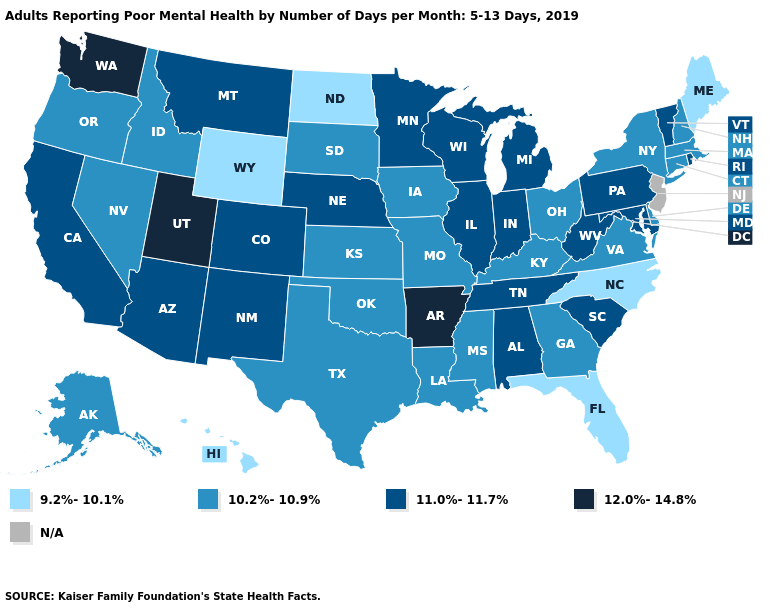Which states hav the highest value in the Northeast?
Be succinct. Pennsylvania, Rhode Island, Vermont. Does the first symbol in the legend represent the smallest category?
Short answer required. Yes. Which states hav the highest value in the MidWest?
Keep it brief. Illinois, Indiana, Michigan, Minnesota, Nebraska, Wisconsin. Among the states that border Massachusetts , which have the lowest value?
Concise answer only. Connecticut, New Hampshire, New York. What is the lowest value in states that border Georgia?
Quick response, please. 9.2%-10.1%. What is the highest value in the MidWest ?
Concise answer only. 11.0%-11.7%. Does Wyoming have the lowest value in the USA?
Write a very short answer. Yes. Which states hav the highest value in the West?
Answer briefly. Utah, Washington. How many symbols are there in the legend?
Concise answer only. 5. What is the lowest value in the USA?
Write a very short answer. 9.2%-10.1%. How many symbols are there in the legend?
Answer briefly. 5. Which states have the highest value in the USA?
Keep it brief. Arkansas, Utah, Washington. What is the lowest value in states that border Indiana?
Give a very brief answer. 10.2%-10.9%. 